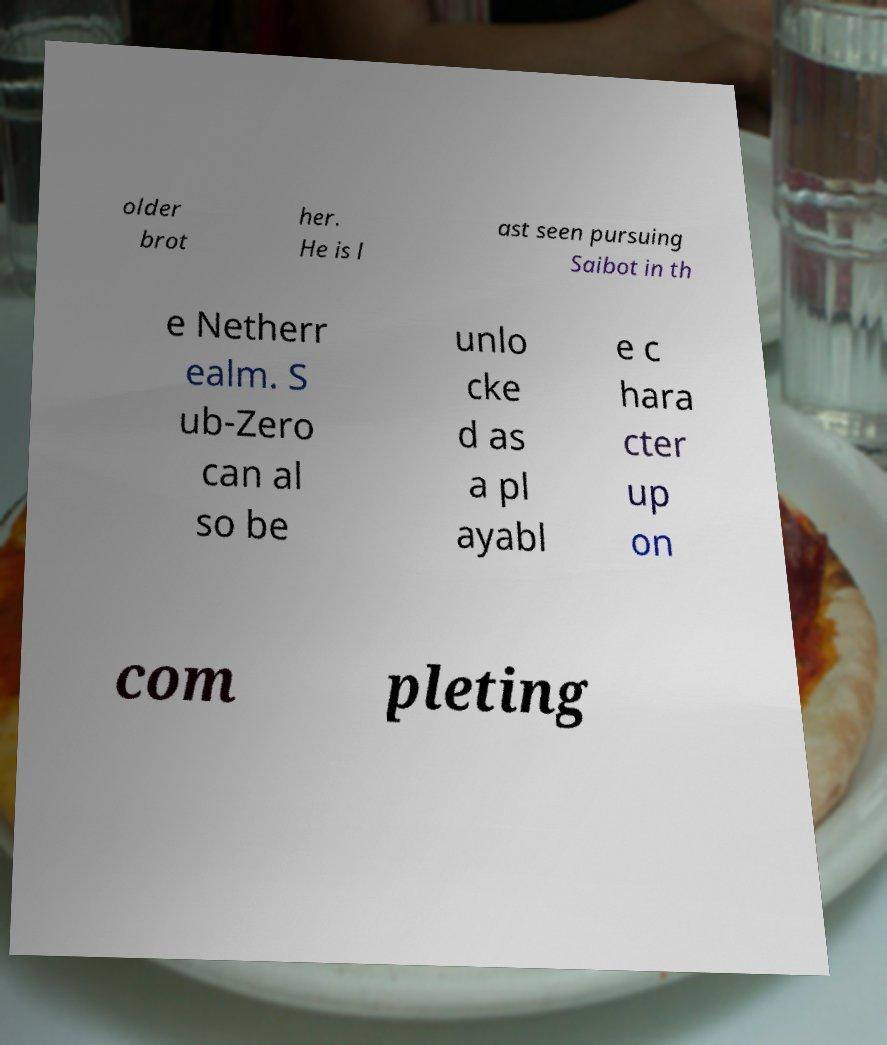Can you accurately transcribe the text from the provided image for me? older brot her. He is l ast seen pursuing Saibot in th e Netherr ealm. S ub-Zero can al so be unlo cke d as a pl ayabl e c hara cter up on com pleting 